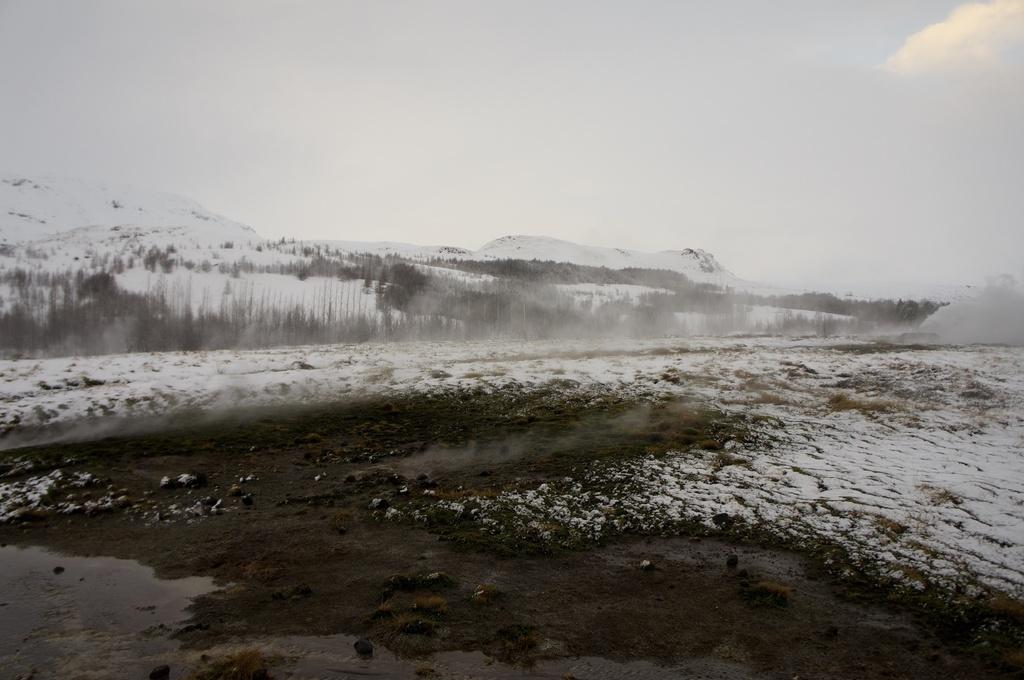What is the color scheme of the image? The image is black and white. What can be seen in the sky in the image? Clouds are present in the sky. What type of geographical feature is visible in the image? There are mountains in the image. What type of vegetation is present in the image? Trees are present in the image. What is covering the ground in the image? The ground is covered with snow. What type of basin is visible in the image? There is no basin present in the image. What message of hope can be seen in the image? The image does not convey any specific message of hope; it is a landscape scene with mountains, trees, sky, and snow. 